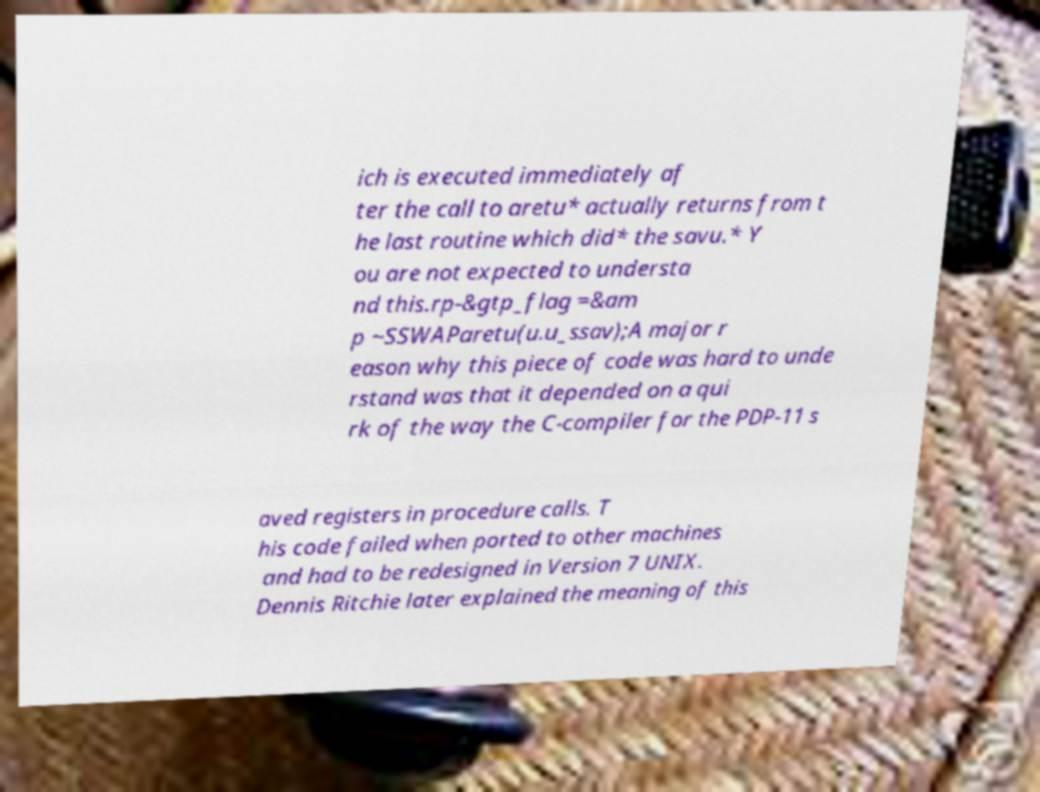Please identify and transcribe the text found in this image. ich is executed immediately af ter the call to aretu* actually returns from t he last routine which did* the savu.* Y ou are not expected to understa nd this.rp-&gtp_flag =&am p ~SSWAParetu(u.u_ssav);A major r eason why this piece of code was hard to unde rstand was that it depended on a qui rk of the way the C-compiler for the PDP-11 s aved registers in procedure calls. T his code failed when ported to other machines and had to be redesigned in Version 7 UNIX. Dennis Ritchie later explained the meaning of this 